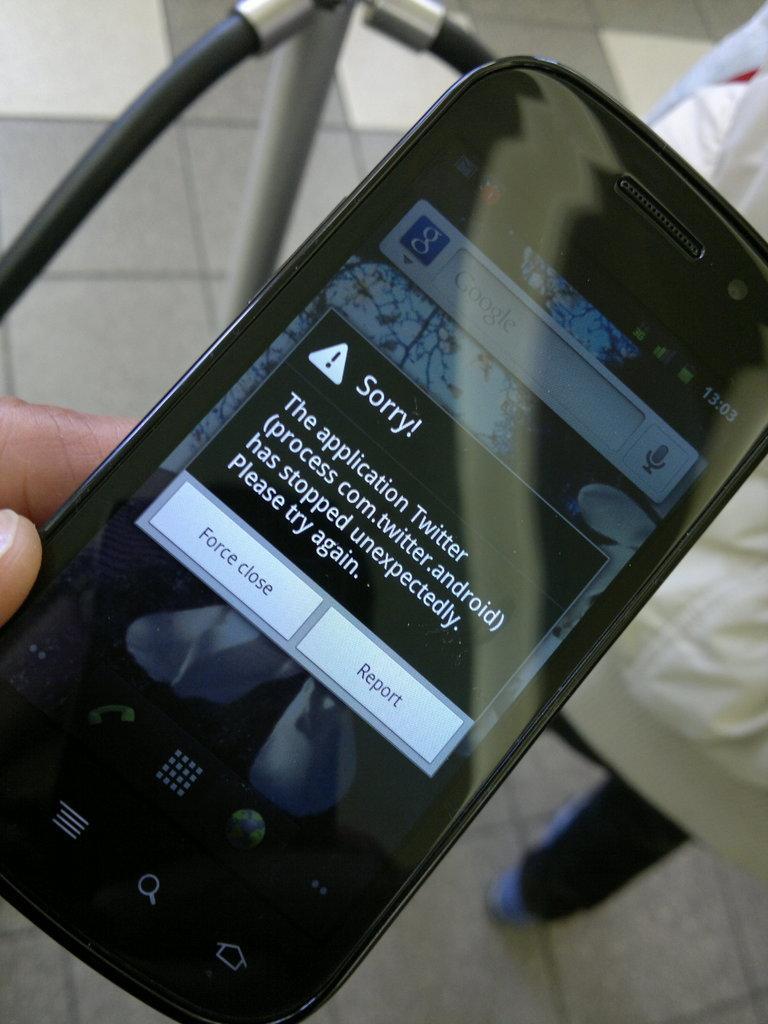Please provide a concise description of this image. In this image, we can see the hand of a person holding a mobile phone, there is a pop up in the mobile phone. 